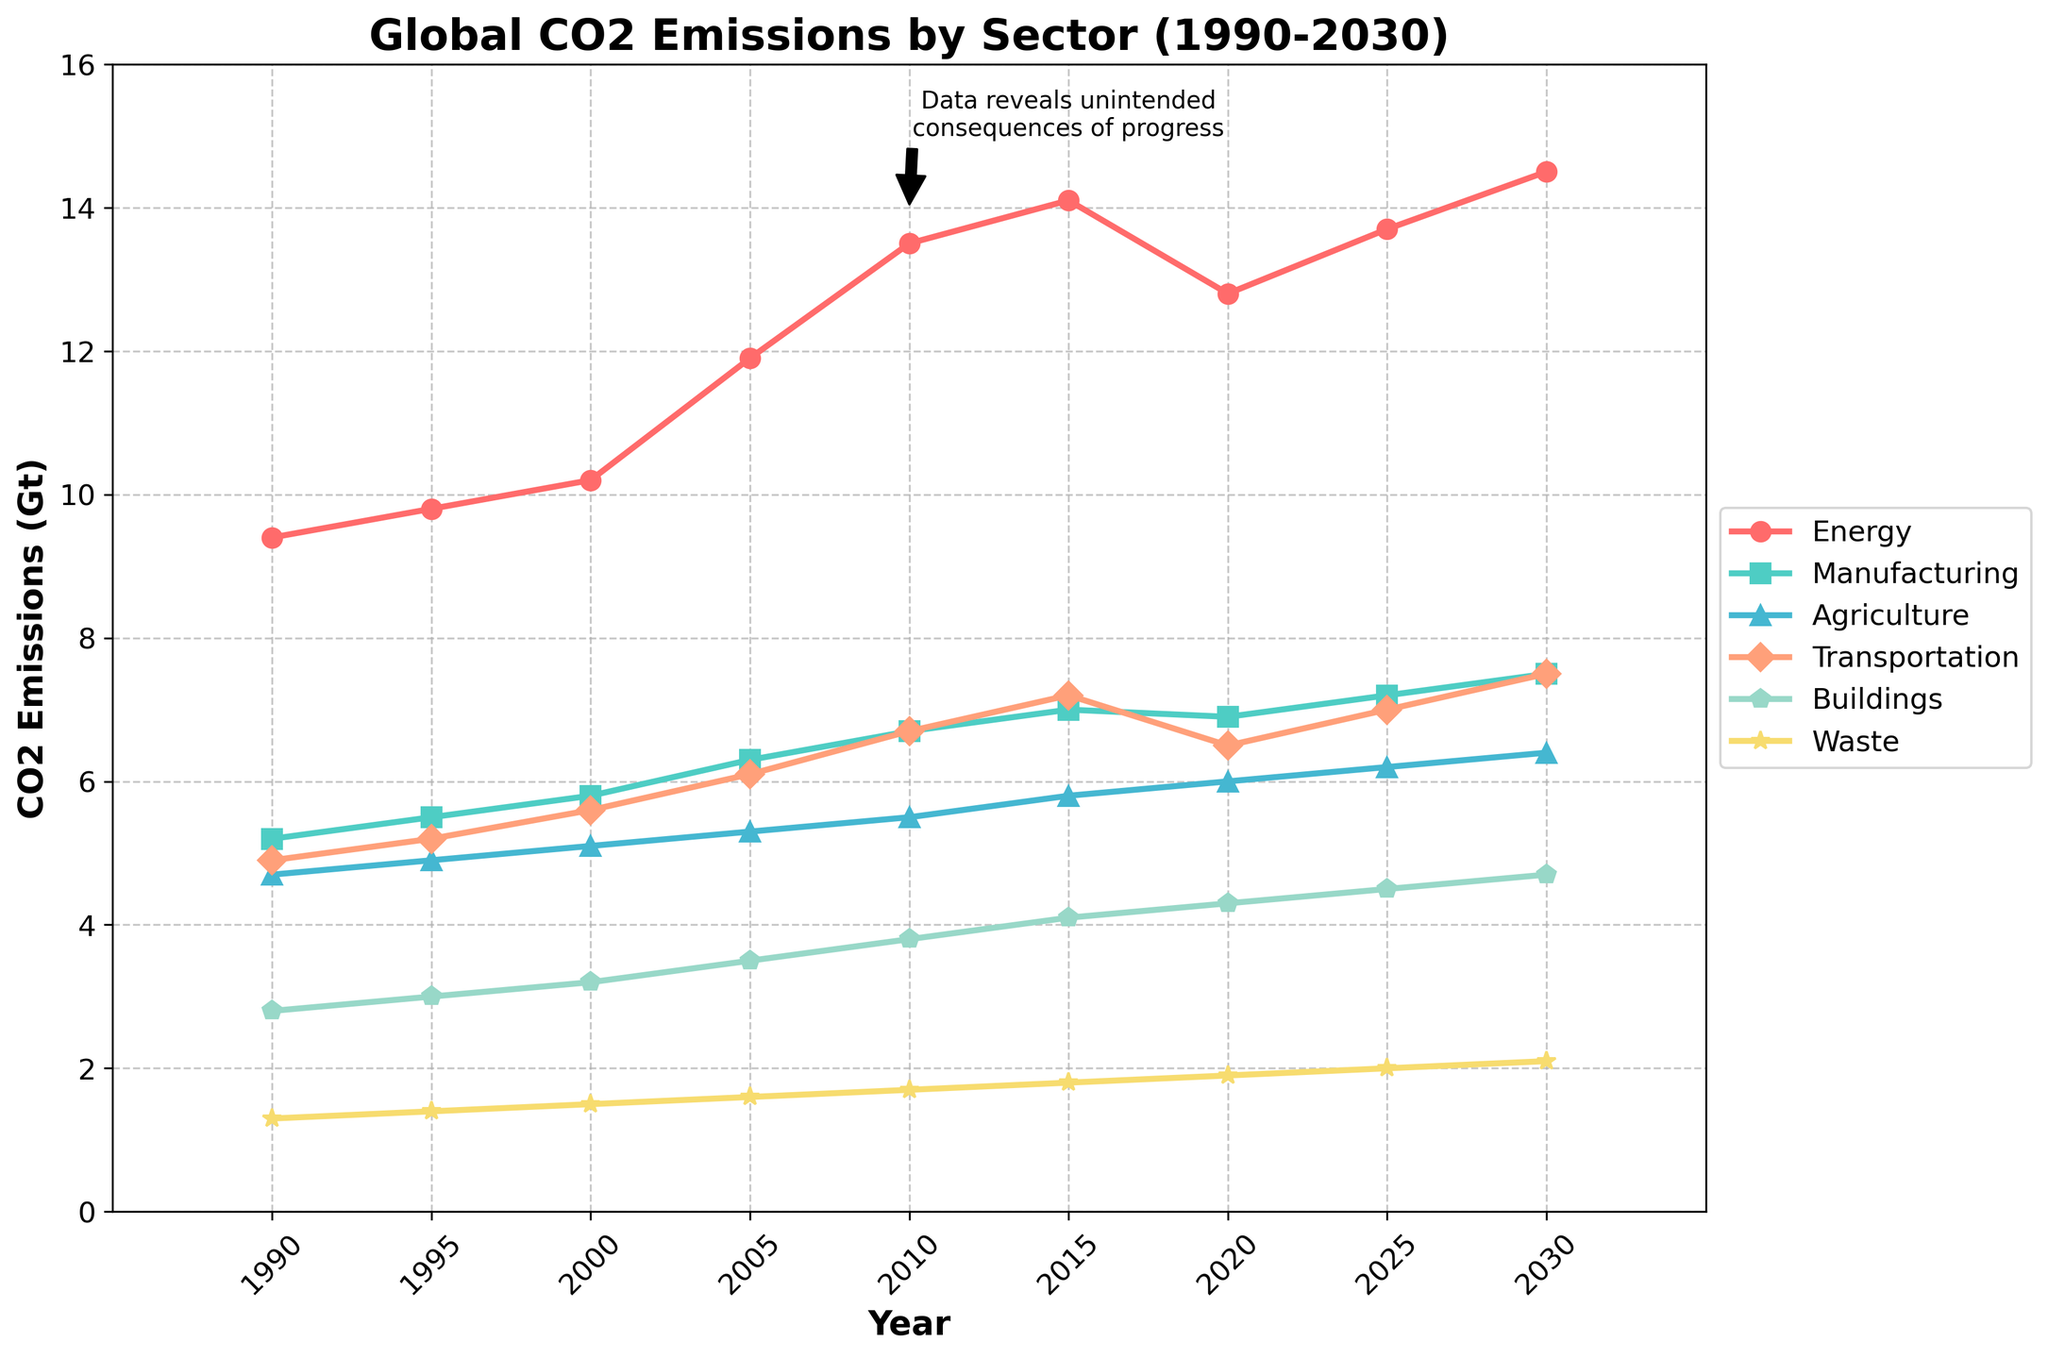What sector showed the highest CO2 emissions in 2010? Look at the data points for each sector in 2010 and compare the values. The Energy sector has the highest value, 13.5 Gt.
Answer: Energy Between 1990 and 2020, which sector had the smallest increase in CO2 emissions? Subtract the 1990 value from the 2020 value for each sector and identify the sector with the smallest difference. Waste increased from 1.3 to 1.9, a difference of 0.6 Gt.
Answer: Waste What is the total CO2 emissions for all sectors combined in 2025? Add the emissions for all sectors in 2025: 13.7 (Energy) + 7.2 (Manufacturing) + 6.2 (Agriculture) + 7.0 (Transportation) + 4.5 (Buildings) + 2.0 (Waste) = 40.6 Gt.
Answer: 40.6 Gt Which sector had the sharpest decline in CO2 emissions between 2015 and 2020? Subtract the 2020 value from the 2015 value for each sector and identify the largest difference. Energy decreased from 14.1 to 12.8, a drop of 1.3 Gt.
Answer: Energy What is the average annual CO2 emissions for the Transportation sector from 1990 to 2030? Sum the emissions from Transportation for all years and divide by the number of years: (4.9+5.2+5.6+6.1+6.7+7.2+6.5+7.0+7.5)/9 ≈ 6.3 Gt.
Answer: 6.3 Gt Which sector is represented by the green line in the visual? Identify the green line and find the corresponding sector from the legend. The green line corresponds to the Agriculture sector.
Answer: Agriculture How much higher were the CO2 emissions from the Buildings sector in 2030 compared to 1990? Subtract the 1990 value from the 2030 value for the Buildings sector: 4.7 - 2.8 = 1.9 Gt.
Answer: 1.9 Gt What is the average CO2 emissions for the Manufacturing sector between 1990 and 2020? Sum the emissions from 1990 to 2020 for Manufacturing and divide by the number of data points: (5.2+5.5+5.8+6.3+6.7+7.0+6.9)/7 ≈ 6.2 Gt.
Answer: 6.2 Gt Which two sectors’ emission lines intersect around the year 2000? Look for the intersection point on the visual around 2000. The Energy and Manufacturing sector lines intersect.
Answer: Energy and Manufacturing 